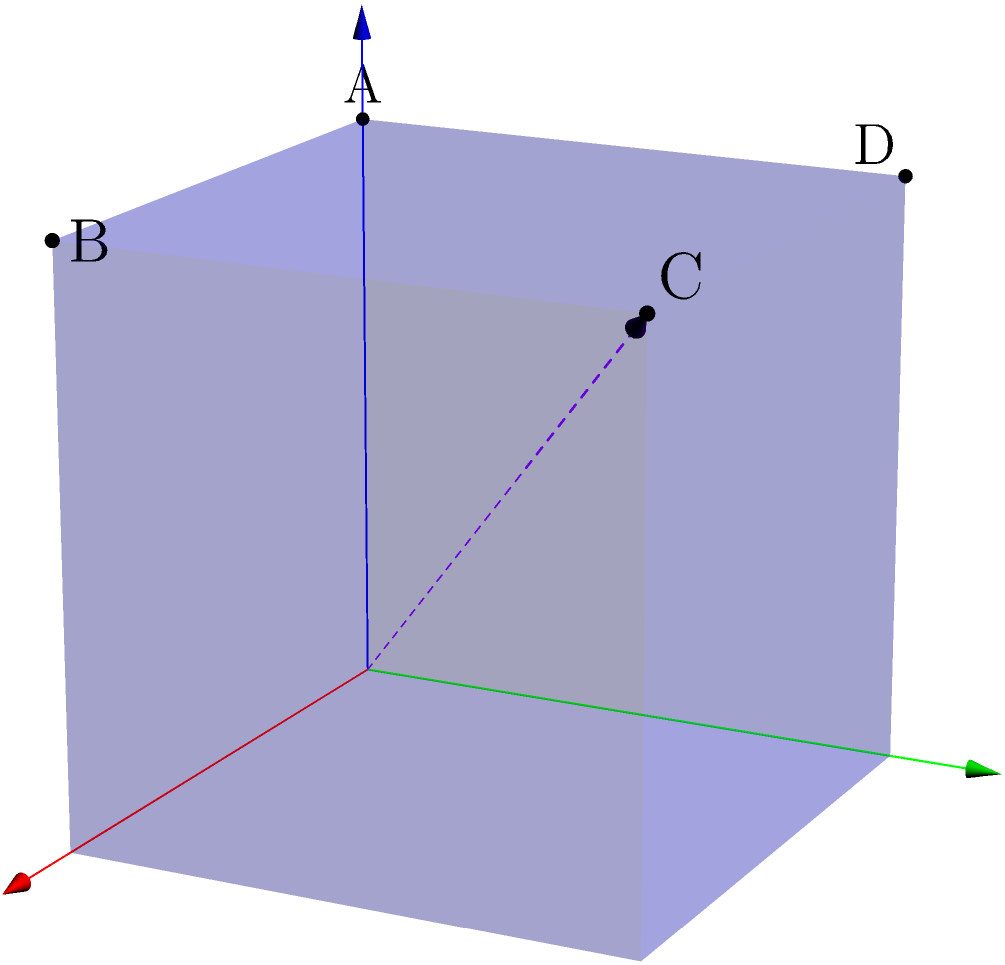A cube-shaped prop is positioned on the stage as shown in the diagram. If this prop is rotated 120° counterclockwise around the axis from the origin (0,0,0) to point C (1,1,1), which point will be at the top of the cube after the rotation? To solve this problem, let's follow these steps:

1. Identify the initial positions:
   - Point A is at (0,0,1)
   - Point B is at (1,0,1)
   - Point C is at (1,1,1)
   - Point D is at (0,1,1)

2. Understand the rotation:
   - The rotation is 120° counterclockwise around the axis from (0,0,0) to (1,1,1)
   - This axis goes through the cube diagonally from one corner to the opposite corner

3. Visualize the rotation:
   - A 120° rotation is 1/3 of a full 360° rotation
   - In a full rotation around this axis, the cube would rotate through three positions before returning to its starting position

4. Track the movement of points:
   - Point A starts at the top
   - After a 120° rotation, point B will move to where A was
   - After another 120° rotation, point D will move to where B was
   - After a final 120° rotation, point A would return to its starting position

5. Conclude:
   - Since we're only doing one 120° rotation, point B will end up at the top of the cube
Answer: B 